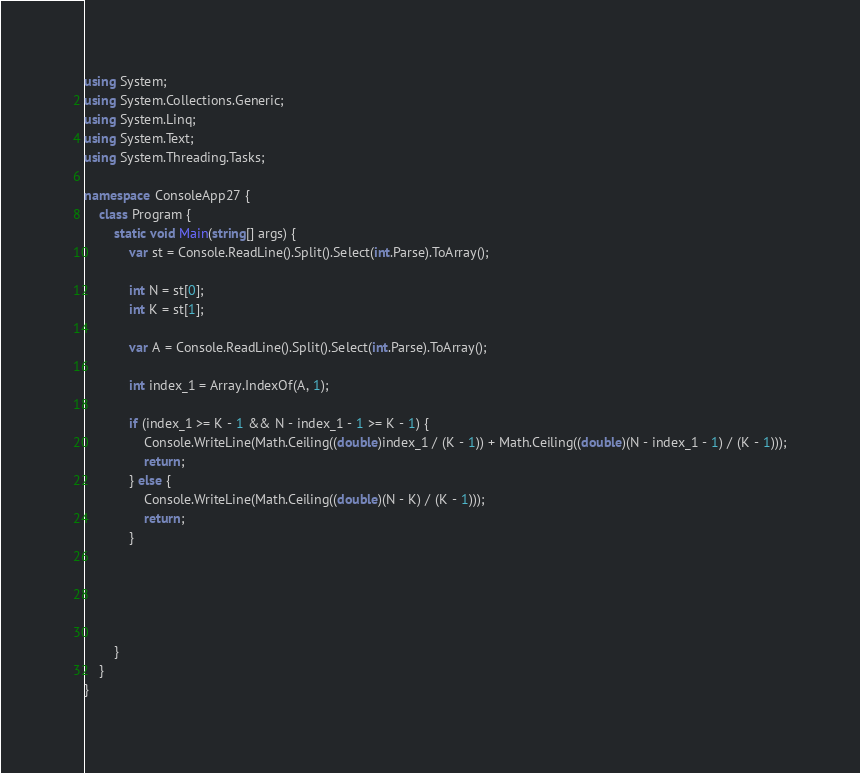<code> <loc_0><loc_0><loc_500><loc_500><_C#_>using System;
using System.Collections.Generic;
using System.Linq;
using System.Text;
using System.Threading.Tasks;

namespace ConsoleApp27 {
    class Program {
        static void Main(string[] args) {
            var st = Console.ReadLine().Split().Select(int.Parse).ToArray();

            int N = st[0];
            int K = st[1];

            var A = Console.ReadLine().Split().Select(int.Parse).ToArray();

            int index_1 = Array.IndexOf(A, 1);

            if (index_1 >= K - 1 && N - index_1 - 1 >= K - 1) {
                Console.WriteLine(Math.Ceiling((double)index_1 / (K - 1)) + Math.Ceiling((double)(N - index_1 - 1) / (K - 1)));
                return;
            } else {
                Console.WriteLine(Math.Ceiling((double)(N - K) / (K - 1)));
                return;
            }



            

        }
    }
}
</code> 